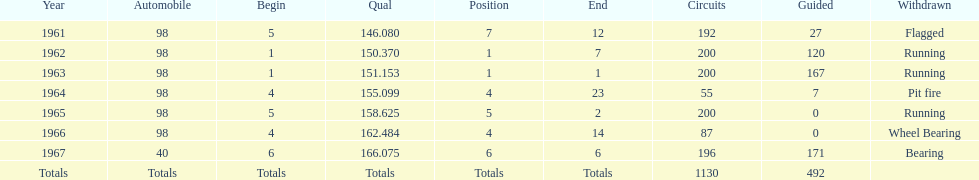Number of times to finish the races running. 3. 